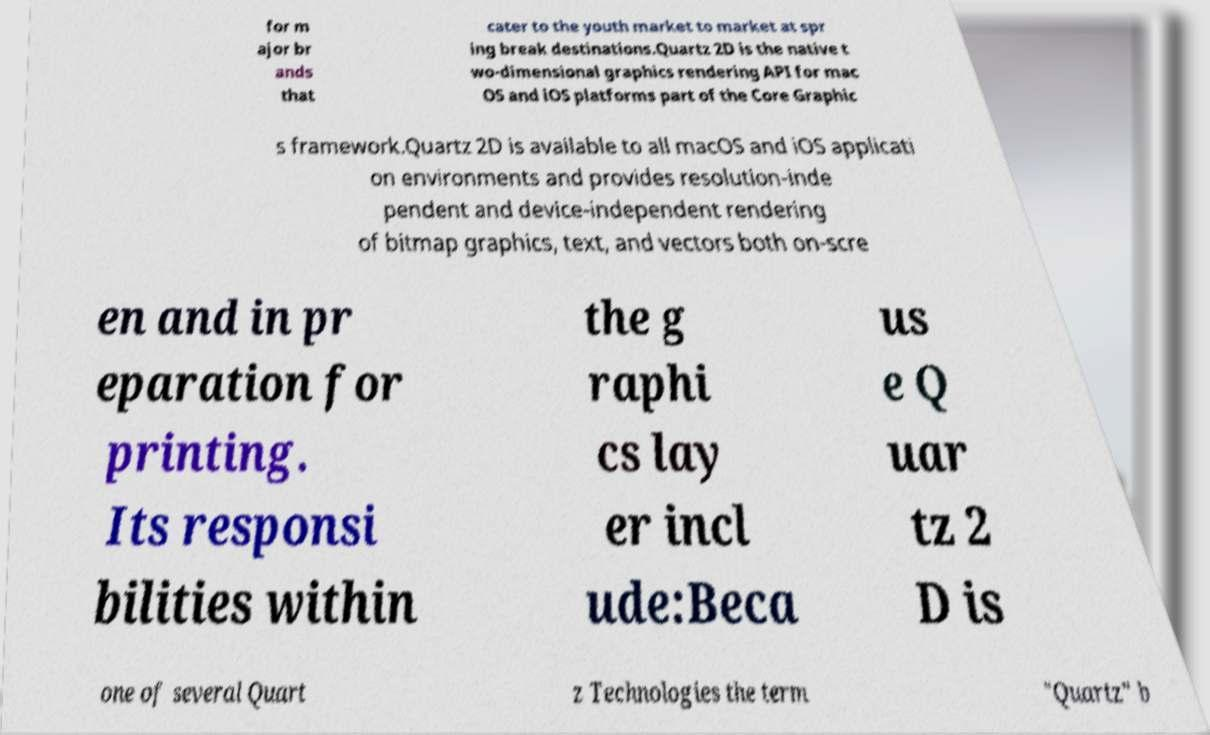I need the written content from this picture converted into text. Can you do that? for m ajor br ands that cater to the youth market to market at spr ing break destinations.Quartz 2D is the native t wo-dimensional graphics rendering API for mac OS and iOS platforms part of the Core Graphic s framework.Quartz 2D is available to all macOS and iOS applicati on environments and provides resolution-inde pendent and device-independent rendering of bitmap graphics, text, and vectors both on-scre en and in pr eparation for printing. Its responsi bilities within the g raphi cs lay er incl ude:Beca us e Q uar tz 2 D is one of several Quart z Technologies the term "Quartz" b 